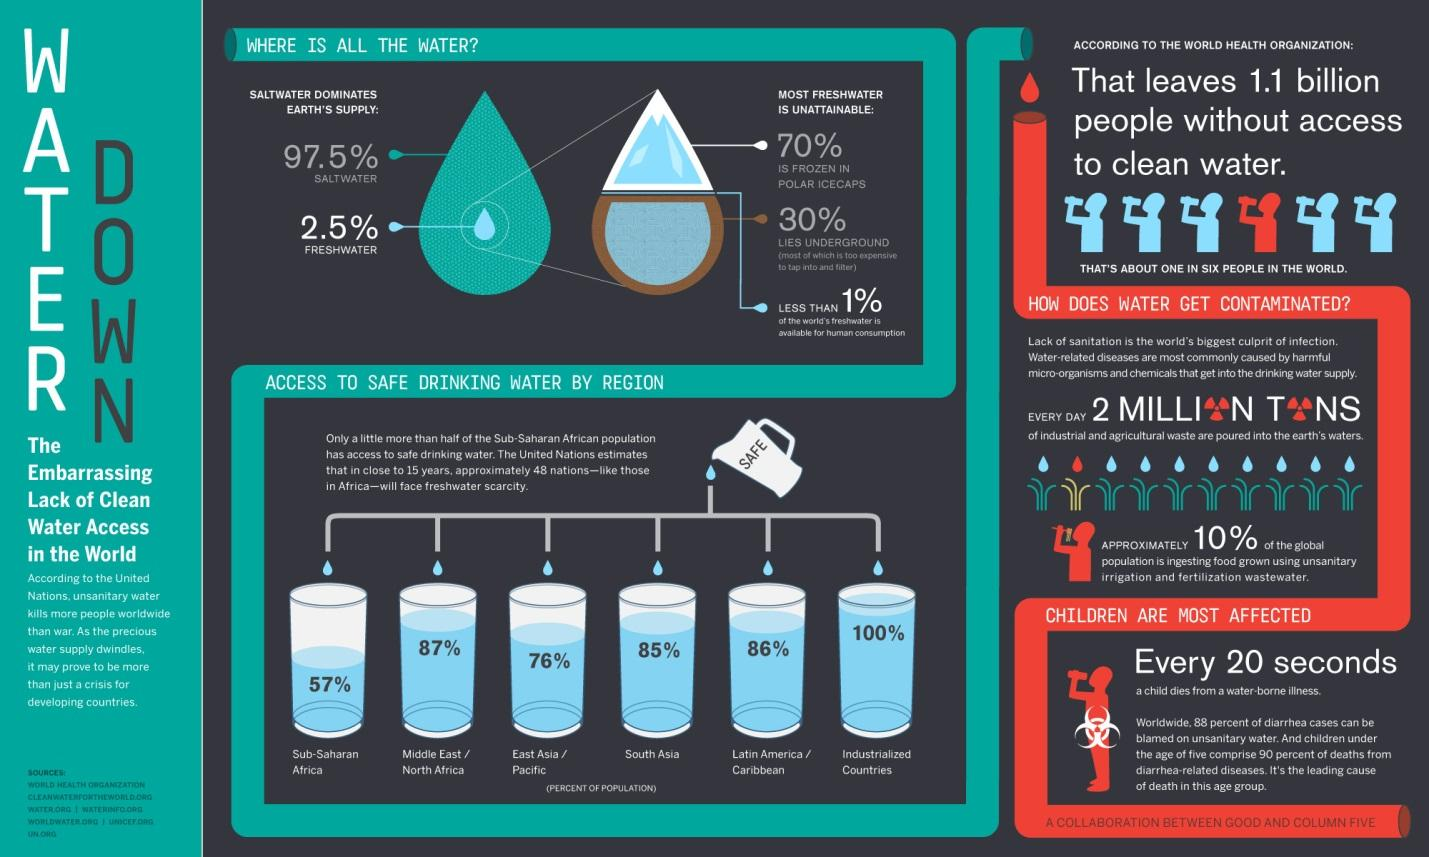Identify some key points in this picture. I declare that approximately 30% of Earth's freshwater can be found underground. 87% of the population in the Middle East and North Africa has access to safe drinking water. It is estimated that 97.5% of the water on the Earth's surface is saline. Only 2.5% of the Earth's water is fresh, making it a crucial and limited resource that must be carefully managed. According to recent data, 85% of the South Asian population has access to safe drinking water. 